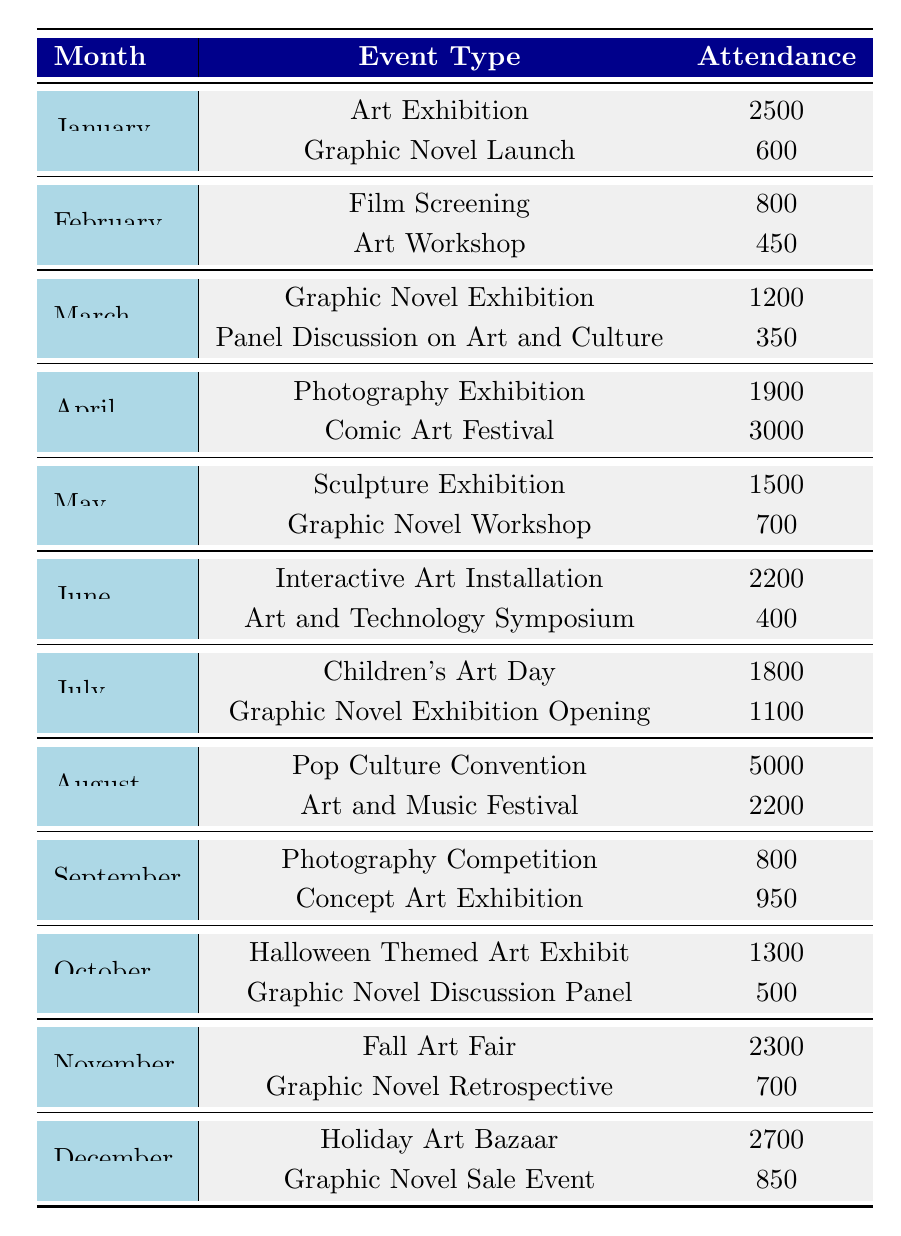What is the attendance for the Graphic Novel Launch in January? The table lists January as the month. The next row for January specifies the event type as Graphic Novel Launch, with an attendance of 600.
Answer: 600 What was the total attendance for all events in April? In April, the events listed are Photography Exhibition with 1900 attendance and Comic Art Festival with 3000 attendance. Summing these gives 1900 + 3000 = 4900.
Answer: 4900 Was the attendance for the Pop Culture Convention the highest for any event type throughout the year? The Pop Culture Convention had an attendance of 5000. By comparing this with the highest attendance from other events, none exceed 5000, confirming it is the highest.
Answer: Yes What is the average attendance for Graphic Novel-related events? The relevant events are Graphic Novel Launch (600), Graphic Novel Exhibition (1200), Graphic Novel Workshop (700), Graphic Novel Exhibition Opening (1100), Graphic Novel Discussion Panel (500), Graphic Novel Retrospective (700), and Graphic Novel Sale Event (850). Summing these gives 600 + 1200 + 700 + 1100 + 500 + 700 + 850 = 4750, with 7 events total. So, the average is 4750 / 7 ≈ 678.57.
Answer: 678.57 Which month had the lowest attendance for an individual event? By reviewing the attendance values, February's lowest event (Art Workshop) had 450, which is lower than all other events.
Answer: 450 What was the total attendance for all events in the first half of the year (January to June)? Adding attendance from January (2500 + 600), February (800 + 450), March (1200 + 350), April (1900 + 3000), May (1500 + 700), June (2200 + 400) gives 2500 + 600 + 800 + 450 + 1200 + 350 + 1900 + 3000 + 1500 + 700 + 2200 + 400 = 18750.
Answer: 18750 Did the attendance for the Comic Art Festival exceed that of the Photography Exhibition in April? The Comic Art Festival had 3000 attendance, while the Photography Exhibition had 1900. Since 3000 is greater than 1900, it confirms that attendance for the Comic Art Festival exceeded that of the Photography Exhibition.
Answer: Yes 